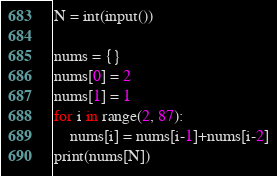Convert code to text. <code><loc_0><loc_0><loc_500><loc_500><_Python_>N = int(input())

nums = {}
nums[0] = 2
nums[1] = 1
for i in range(2, 87):
    nums[i] = nums[i-1]+nums[i-2]
print(nums[N])
</code> 